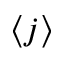<formula> <loc_0><loc_0><loc_500><loc_500>\langle j \rangle</formula> 